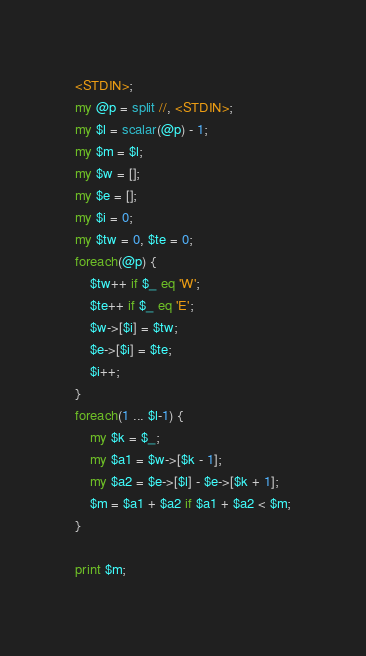Convert code to text. <code><loc_0><loc_0><loc_500><loc_500><_Perl_><STDIN>;
my @p = split //, <STDIN>;
my $l = scalar(@p) - 1;
my $m = $l;
my $w = [];
my $e = [];
my $i = 0;
my $tw = 0, $te = 0;
foreach(@p) {
    $tw++ if $_ eq 'W';
    $te++ if $_ eq 'E';
    $w->[$i] = $tw;
    $e->[$i] = $te;
    $i++;
}
foreach(1 ... $l-1) {
    my $k = $_;
    my $a1 = $w->[$k - 1];
    my $a2 = $e->[$l] - $e->[$k + 1];
    $m = $a1 + $a2 if $a1 + $a2 < $m;
}

print $m;</code> 